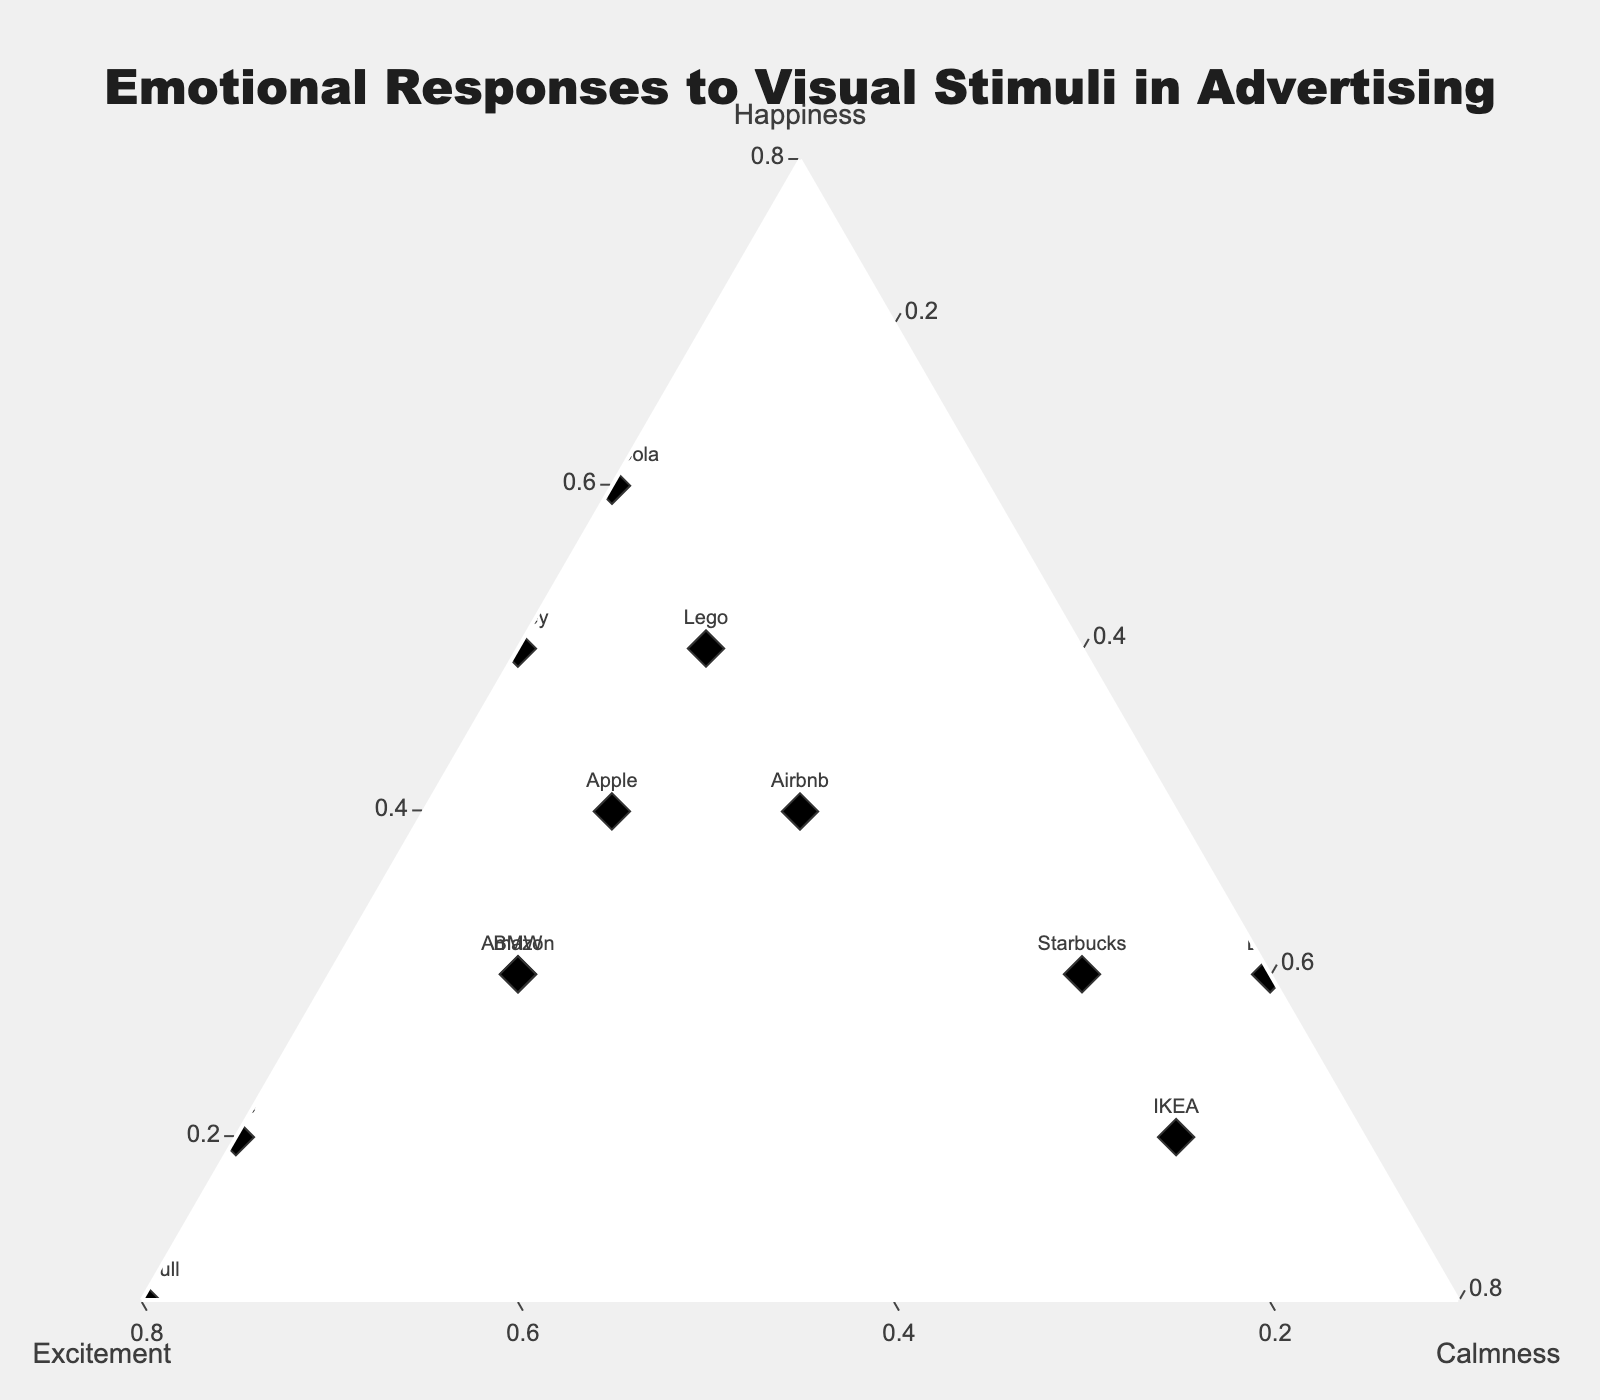What is the title of the figure? The title of a figure is usually found at the top of the chart. In this ternary plot, the title is given in a prominent position above the plot area.
Answer: Emotional Responses to Visual Stimuli in Advertising Which brand has the highest level of excitement? By examining the vertical axis labeled 'Excitement', we can locate the point that is farthest from the opposite axis, which corresponds to the highest value.
Answer: Red Bull Which brand shows the highest level of calmness? To find this, we look along the axis labeled 'Calmness' and locate the point farthest from the opposite axis.
Answer: Dove How many brands are plotted in the figure? To determine this, we need to count the number of points or markers, each representing a different brand, plotted on the ternary diagram.
Answer: 12 Which brand has equal levels of happiness and excitement? Equal levels of happiness and excitement means the points lie equidistant from the 'Happiness' and 'Excitement' axes. Check for the brand where the respective values are identical.
Answer: Apple What is the sum of happiness and calmness for Coca-Cola? From the data, Coca-Cola's happiness level is 0.6, and its calmness level is 0.1. Adding these values together will provide the sum.
Answer: 0.7 Which brand shows a significant difference between excitement and calmness levels? Identify the brands where the difference between the 'Excitement' and 'Calmness' levels is the highest by observing the plot and calculating the differences.
Answer: Nike or Red Bull Compare the emotional response in terms of happiness between Lego and Disney. Which brand evokes a higher happiness level? Locate the points for both Lego and Disney along the 'Happiness' axis and compare their positions to determine which has the higher value.
Answer: Tie (Both are 0.5) Which brands are positioned closest to the center of the ternary plot, indicating a balanced emotional response across all categories? Points near the center of the plot should have nearly equal values for happiness, excitement, and calmness, indicating a balanced response.
Answer: Apple and Airbnb 